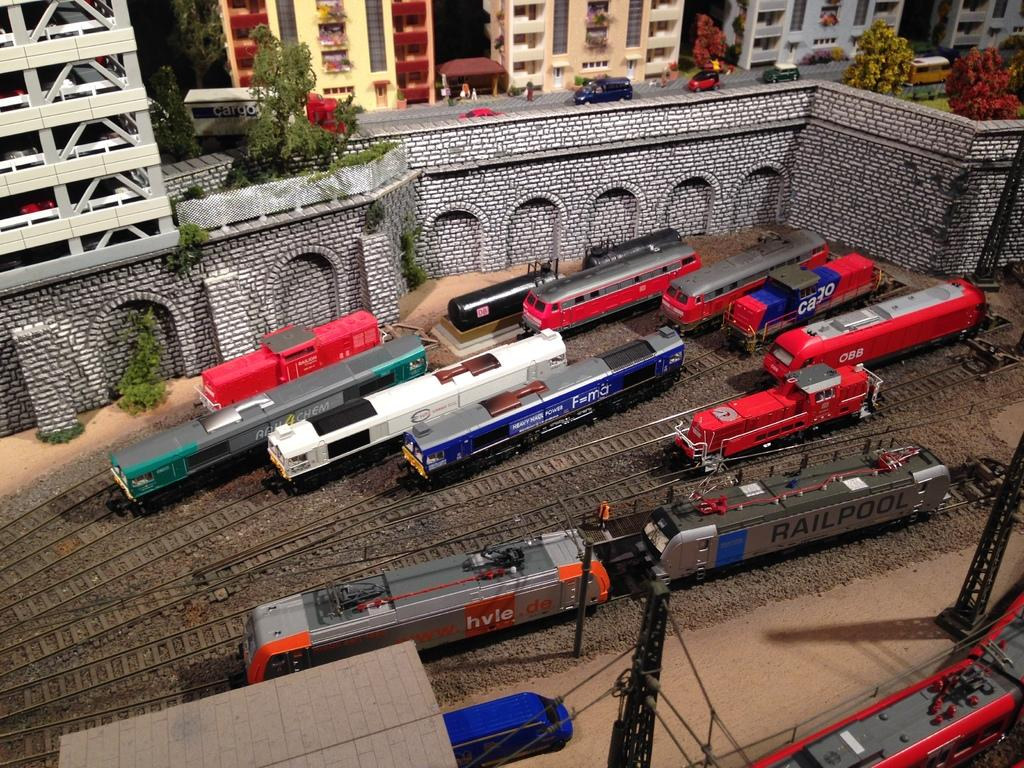What type of transportation infrastructure is visible in the image? There are railway tracks and trains in the image. What other structures can be seen in the image? There are poles, cables, a platform, buildings, trees, vehicles, and a wall visible in the image. Can you see any passengers waiting for the train in the image? There is no indication of passengers waiting for the train in the image. Is there any quicksand present in the image? There is no quicksand present in the image. Are there any advertisements visible on the trains or platforms in the image? There is no mention of advertisements in the provided facts, so we cannot determine if they are present in the image. 